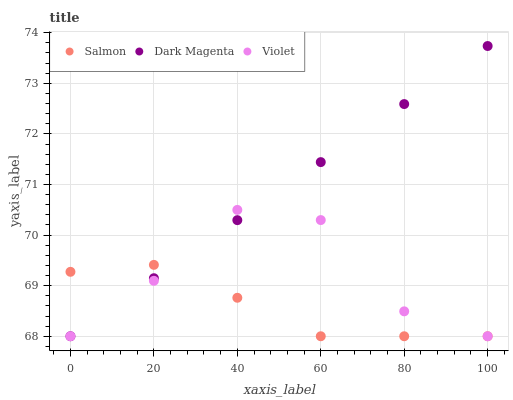Does Salmon have the minimum area under the curve?
Answer yes or no. Yes. Does Dark Magenta have the maximum area under the curve?
Answer yes or no. Yes. Does Violet have the minimum area under the curve?
Answer yes or no. No. Does Violet have the maximum area under the curve?
Answer yes or no. No. Is Dark Magenta the smoothest?
Answer yes or no. Yes. Is Violet the roughest?
Answer yes or no. Yes. Is Violet the smoothest?
Answer yes or no. No. Is Dark Magenta the roughest?
Answer yes or no. No. Does Salmon have the lowest value?
Answer yes or no. Yes. Does Dark Magenta have the highest value?
Answer yes or no. Yes. Does Violet have the highest value?
Answer yes or no. No. Does Violet intersect Salmon?
Answer yes or no. Yes. Is Violet less than Salmon?
Answer yes or no. No. Is Violet greater than Salmon?
Answer yes or no. No. 